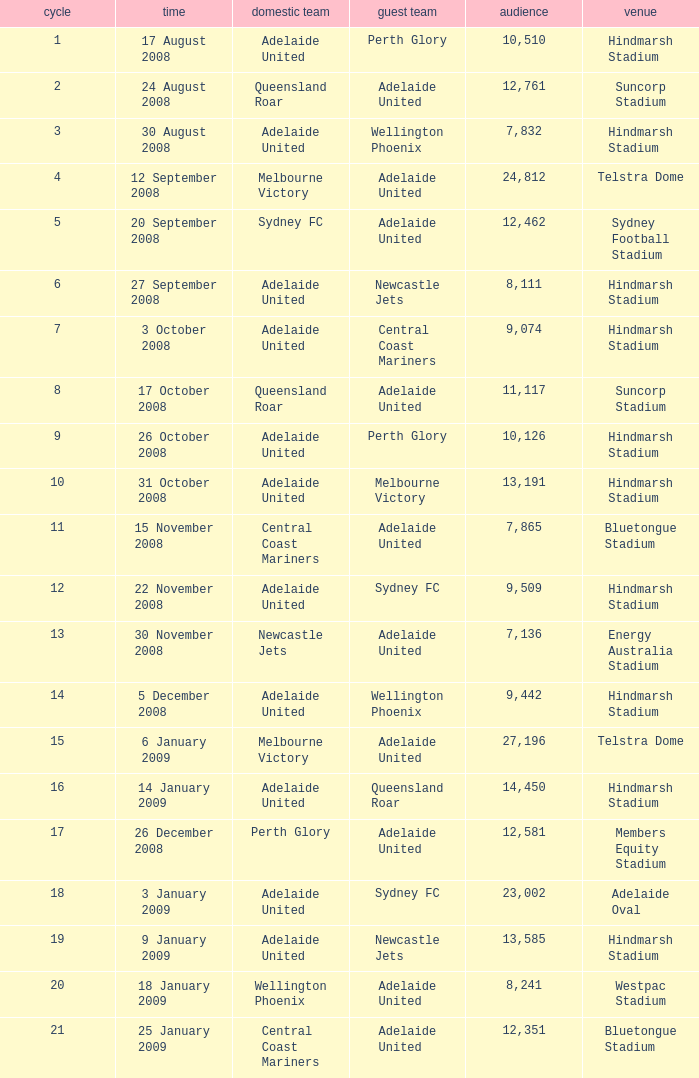Who was the away team when Queensland Roar was the home team in the round less than 3? Adelaide United. 